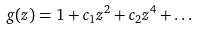<formula> <loc_0><loc_0><loc_500><loc_500>g ( z ) = 1 + c _ { 1 } z ^ { 2 } + c _ { 2 } z ^ { 4 } + \dots</formula> 